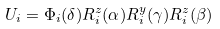Convert formula to latex. <formula><loc_0><loc_0><loc_500><loc_500>U _ { i } = \Phi _ { i } ( \delta ) R _ { i } ^ { z } ( \alpha ) R _ { i } ^ { y } ( \gamma ) R _ { i } ^ { z } ( \beta )</formula> 